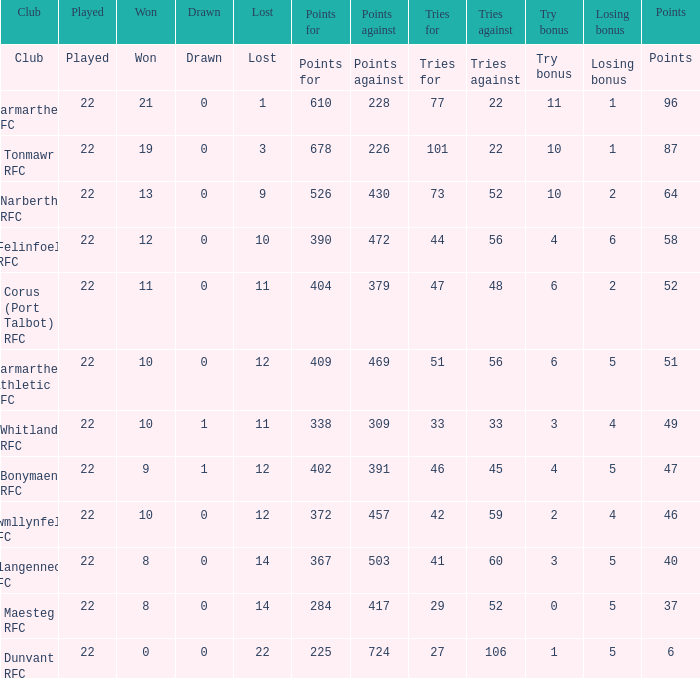List the opposing arguments for 51 points. 469.0. 